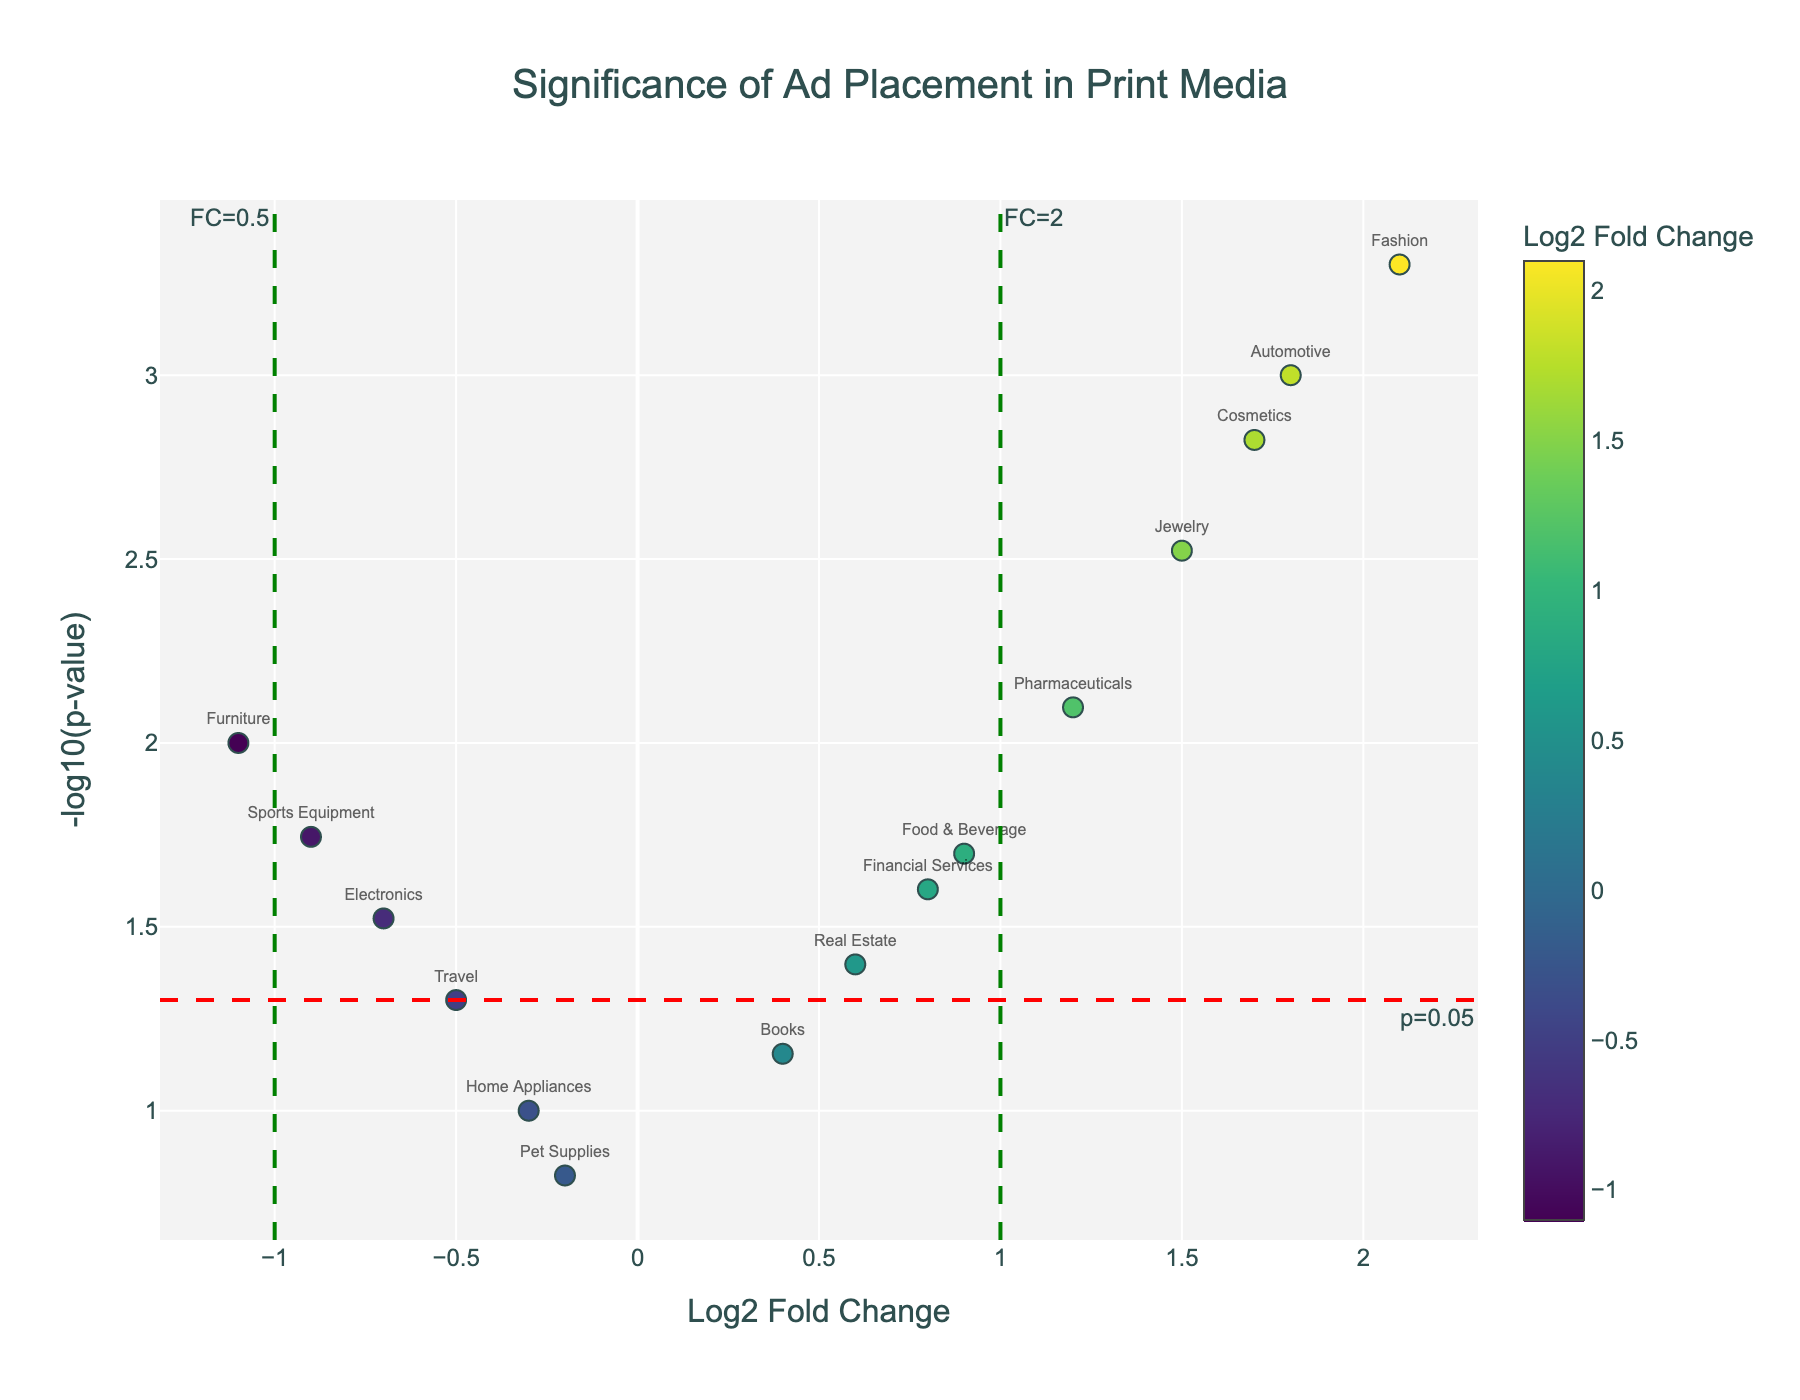What's the title of the figure? The figure's title is displayed at the top in large, bold font. It says, "Significance of Ad Placement in Print Media".
Answer: Significance of Ad Placement in Print Media How many product categories are displayed in the plot? Each marker represents a product category. By counting the markers, you see there are 15 categories.
Answer: 15 Which product category has the highest significance? The significance is represented by the -log10(p-value), and the highest significance will correspond to the point with the highest y-value. Fashion has the highest y-value.
Answer: Fashion How many categories show a log2 fold change greater than 1? To find this, count the number of markers to the right of 1 on the x-axis. These categories are Automotive, Fashion, Pharmaceuticals, Jewelry, Cosmetics.
Answer: 5 Which ad placement has the lowest log2 fold change and what is its corresponding product category? The lowest log2 fold change is located on the far left of the plot. The marker for Furniture, which has Classified Section as its ad placement, is positioned farthest to the left.
Answer: Classified Section for Furniture How many product categories fall below the significance threshold (p=0.05)? The significance threshold for p=0.05 is marked by a horizontal line. Count the markers that fall below this line. These categories are Home Appliances and Pet Supplies.
Answer: 2 Are there any ad placements categorized as fashion with a p-value below 0.001? Examine the plot to see if any category labeled "Fashion" falls above the p-value threshold line at -log10(0.001). Fashion, with a -log10(p-value) higher than 3, meets this criterion.
Answer: Yes Which products are significantly affected by their ad placements but show a negative log2 fold change? Significantly affected categories have -log10(p-values) above the threshold line at -log10(0.05) and a negative log2 fold change on the x-axis. These are Electronics, Sports Equipment, and Furniture.
Answer: Electronics, Sports Equipment, Furniture What is the log2 fold change and p-value for the Electronics category? Look for the Electronics data point and check the hover text for log2 fold change and p-value displayed in the plot.
Answer: Log2 fold change: -0.7, p-value: 0.03 Which category has a log2 fold change of 1.5 and what is its ad placement? Locate the marker on the plot which corresponds to a log2 fold change of 1.5 and check its hover text for the category and ad placement. The Jewelry category matches this log2 fold change.
Answer: Jewelry with Special Insert 